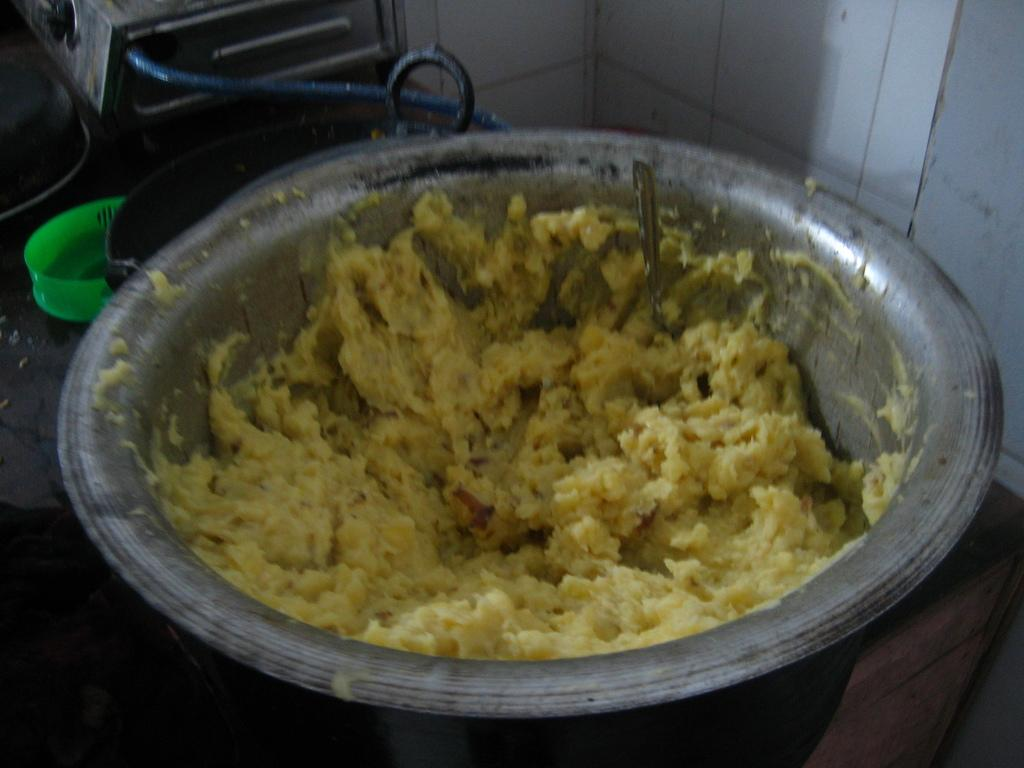What is in the bowl that is visible in the image? There is a bowl with food in the image. What utensil is present in the image? There is a spoon in the image. What is used for cooking in the image? There is a pan and a gas stove in the image. What is the background of the image? There is a wall in the image. Can you describe any other objects in the image? There are other unspecified objects in the image. What type of rod can be seen holding up the ceiling in the image? There is no rod holding up the ceiling in the image; it is not mentioned in the provided facts. 